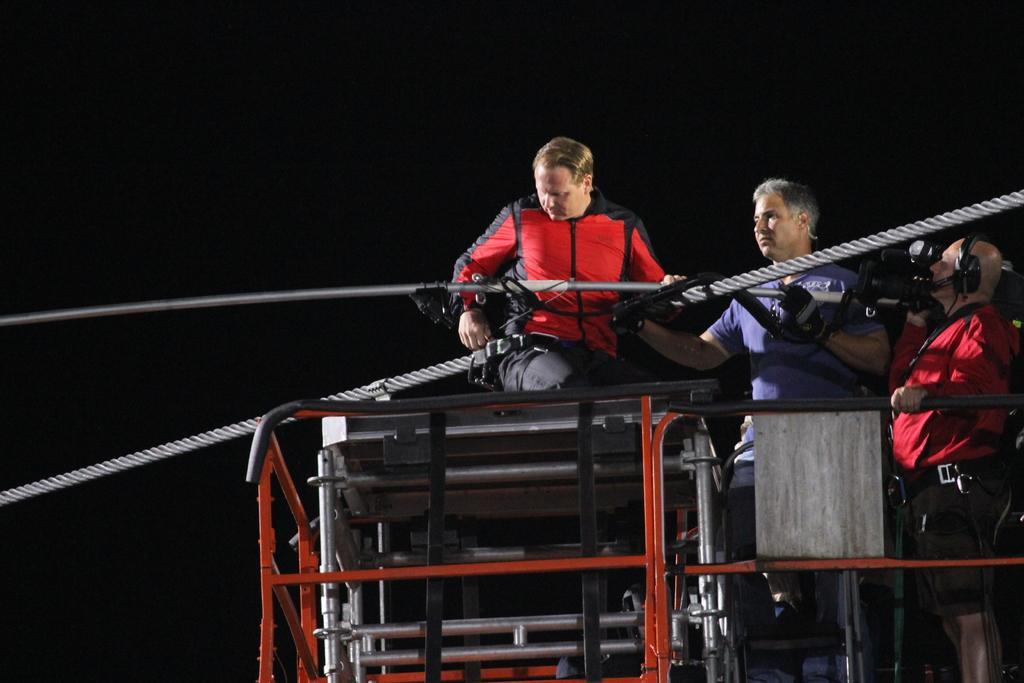In one or two sentences, can you explain what this image depicts? On the right there are two persons standing on a metal object and among them a man is holding a camera in his hand and there is a person in squat position on a platform and we can see a rope and poles. 